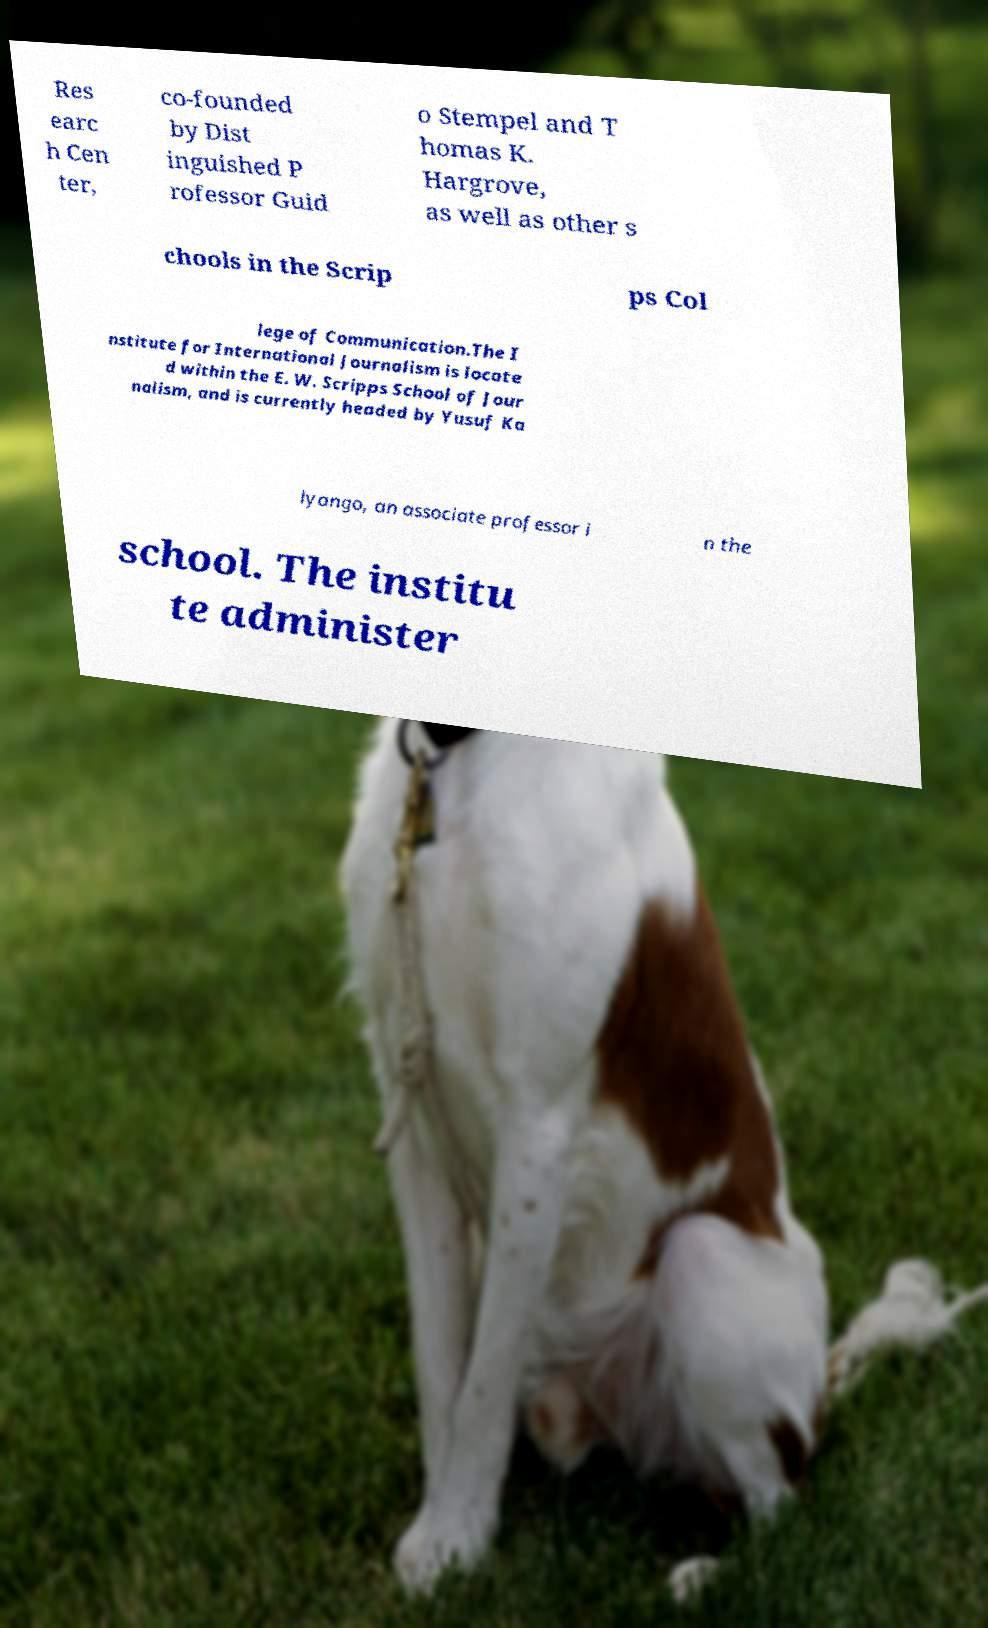For documentation purposes, I need the text within this image transcribed. Could you provide that? Res earc h Cen ter, co-founded by Dist inguished P rofessor Guid o Stempel and T homas K. Hargrove, as well as other s chools in the Scrip ps Col lege of Communication.The I nstitute for International Journalism is locate d within the E. W. Scripps School of Jour nalism, and is currently headed by Yusuf Ka lyango, an associate professor i n the school. The institu te administer 